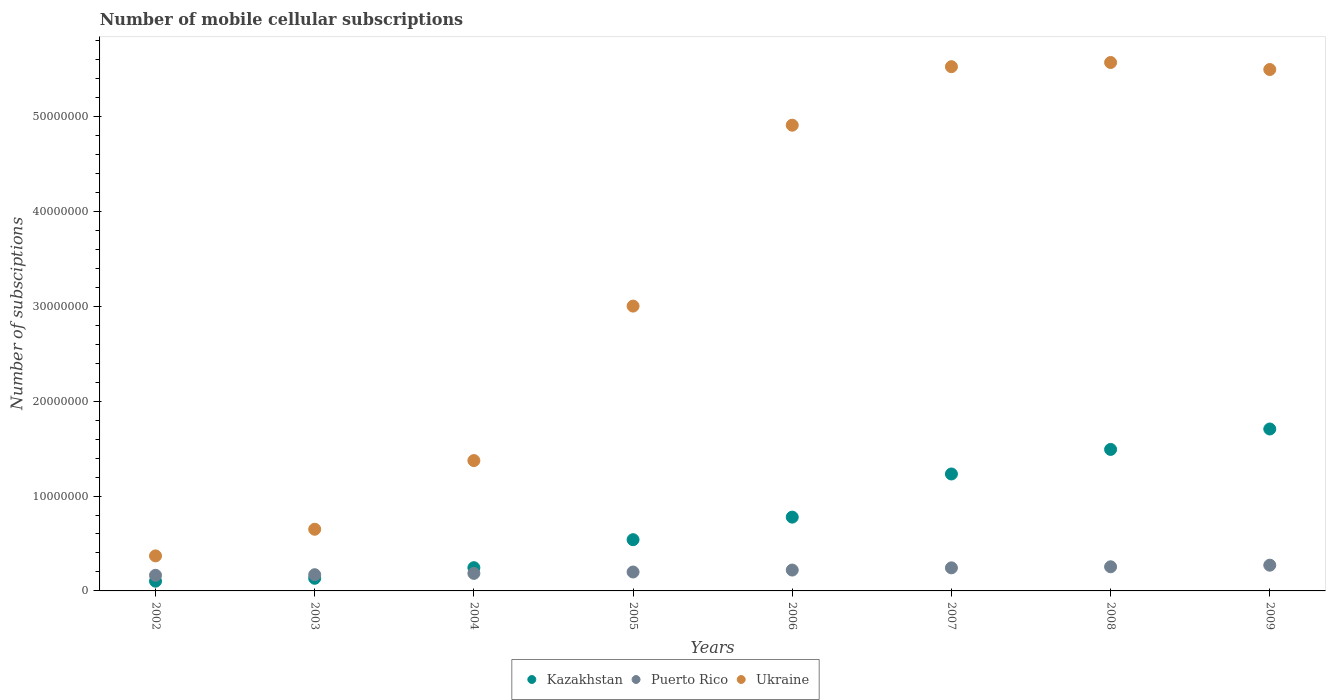What is the number of mobile cellular subscriptions in Kazakhstan in 2004?
Provide a succinct answer. 2.45e+06. Across all years, what is the maximum number of mobile cellular subscriptions in Kazakhstan?
Offer a very short reply. 1.71e+07. Across all years, what is the minimum number of mobile cellular subscriptions in Kazakhstan?
Your answer should be compact. 1.03e+06. In which year was the number of mobile cellular subscriptions in Puerto Rico maximum?
Your answer should be very brief. 2009. In which year was the number of mobile cellular subscriptions in Puerto Rico minimum?
Provide a succinct answer. 2002. What is the total number of mobile cellular subscriptions in Kazakhstan in the graph?
Offer a terse response. 6.23e+07. What is the difference between the number of mobile cellular subscriptions in Puerto Rico in 2004 and that in 2008?
Ensure brevity in your answer.  -6.96e+05. What is the difference between the number of mobile cellular subscriptions in Puerto Rico in 2006 and the number of mobile cellular subscriptions in Kazakhstan in 2007?
Provide a succinct answer. -1.01e+07. What is the average number of mobile cellular subscriptions in Kazakhstan per year?
Keep it short and to the point. 7.78e+06. In the year 2006, what is the difference between the number of mobile cellular subscriptions in Ukraine and number of mobile cellular subscriptions in Kazakhstan?
Your response must be concise. 4.13e+07. What is the ratio of the number of mobile cellular subscriptions in Kazakhstan in 2005 to that in 2007?
Provide a succinct answer. 0.44. Is the difference between the number of mobile cellular subscriptions in Ukraine in 2003 and 2006 greater than the difference between the number of mobile cellular subscriptions in Kazakhstan in 2003 and 2006?
Provide a succinct answer. No. What is the difference between the highest and the second highest number of mobile cellular subscriptions in Kazakhstan?
Make the answer very short. 2.15e+06. What is the difference between the highest and the lowest number of mobile cellular subscriptions in Puerto Rico?
Your answer should be very brief. 1.07e+06. Is the sum of the number of mobile cellular subscriptions in Kazakhstan in 2002 and 2006 greater than the maximum number of mobile cellular subscriptions in Ukraine across all years?
Offer a terse response. No. Is it the case that in every year, the sum of the number of mobile cellular subscriptions in Kazakhstan and number of mobile cellular subscriptions in Ukraine  is greater than the number of mobile cellular subscriptions in Puerto Rico?
Provide a short and direct response. Yes. Does the number of mobile cellular subscriptions in Ukraine monotonically increase over the years?
Make the answer very short. No. Is the number of mobile cellular subscriptions in Kazakhstan strictly greater than the number of mobile cellular subscriptions in Ukraine over the years?
Provide a succinct answer. No. How many dotlines are there?
Your response must be concise. 3. How many years are there in the graph?
Offer a terse response. 8. What is the difference between two consecutive major ticks on the Y-axis?
Your answer should be compact. 1.00e+07. Does the graph contain grids?
Provide a succinct answer. No. Where does the legend appear in the graph?
Offer a very short reply. Bottom center. How are the legend labels stacked?
Offer a terse response. Horizontal. What is the title of the graph?
Provide a succinct answer. Number of mobile cellular subscriptions. What is the label or title of the Y-axis?
Give a very brief answer. Number of subsciptions. What is the Number of subsciptions of Kazakhstan in 2002?
Keep it short and to the point. 1.03e+06. What is the Number of subsciptions of Puerto Rico in 2002?
Provide a short and direct response. 1.65e+06. What is the Number of subsciptions in Ukraine in 2002?
Offer a terse response. 3.69e+06. What is the Number of subsciptions of Kazakhstan in 2003?
Keep it short and to the point. 1.33e+06. What is the Number of subsciptions in Puerto Rico in 2003?
Your response must be concise. 1.71e+06. What is the Number of subsciptions of Ukraine in 2003?
Offer a very short reply. 6.50e+06. What is the Number of subsciptions of Kazakhstan in 2004?
Give a very brief answer. 2.45e+06. What is the Number of subsciptions in Puerto Rico in 2004?
Offer a very short reply. 1.85e+06. What is the Number of subsciptions of Ukraine in 2004?
Keep it short and to the point. 1.37e+07. What is the Number of subsciptions of Kazakhstan in 2005?
Your response must be concise. 5.40e+06. What is the Number of subsciptions in Puerto Rico in 2005?
Provide a short and direct response. 1.99e+06. What is the Number of subsciptions in Ukraine in 2005?
Make the answer very short. 3.00e+07. What is the Number of subsciptions in Kazakhstan in 2006?
Ensure brevity in your answer.  7.78e+06. What is the Number of subsciptions of Puerto Rico in 2006?
Give a very brief answer. 2.20e+06. What is the Number of subsciptions of Ukraine in 2006?
Provide a succinct answer. 4.91e+07. What is the Number of subsciptions of Kazakhstan in 2007?
Give a very brief answer. 1.23e+07. What is the Number of subsciptions of Puerto Rico in 2007?
Provide a short and direct response. 2.43e+06. What is the Number of subsciptions of Ukraine in 2007?
Provide a short and direct response. 5.52e+07. What is the Number of subsciptions in Kazakhstan in 2008?
Your answer should be compact. 1.49e+07. What is the Number of subsciptions of Puerto Rico in 2008?
Provide a short and direct response. 2.54e+06. What is the Number of subsciptions of Ukraine in 2008?
Make the answer very short. 5.57e+07. What is the Number of subsciptions in Kazakhstan in 2009?
Your answer should be compact. 1.71e+07. What is the Number of subsciptions of Puerto Rico in 2009?
Make the answer very short. 2.71e+06. What is the Number of subsciptions of Ukraine in 2009?
Ensure brevity in your answer.  5.49e+07. Across all years, what is the maximum Number of subsciptions in Kazakhstan?
Provide a short and direct response. 1.71e+07. Across all years, what is the maximum Number of subsciptions of Puerto Rico?
Ensure brevity in your answer.  2.71e+06. Across all years, what is the maximum Number of subsciptions of Ukraine?
Give a very brief answer. 5.57e+07. Across all years, what is the minimum Number of subsciptions in Kazakhstan?
Make the answer very short. 1.03e+06. Across all years, what is the minimum Number of subsciptions of Puerto Rico?
Keep it short and to the point. 1.65e+06. Across all years, what is the minimum Number of subsciptions in Ukraine?
Offer a terse response. 3.69e+06. What is the total Number of subsciptions of Kazakhstan in the graph?
Offer a very short reply. 6.23e+07. What is the total Number of subsciptions in Puerto Rico in the graph?
Provide a short and direct response. 1.71e+07. What is the total Number of subsciptions of Ukraine in the graph?
Make the answer very short. 2.69e+08. What is the difference between the Number of subsciptions in Kazakhstan in 2002 and that in 2003?
Offer a terse response. -3.04e+05. What is the difference between the Number of subsciptions in Puerto Rico in 2002 and that in 2003?
Your response must be concise. -6.21e+04. What is the difference between the Number of subsciptions of Ukraine in 2002 and that in 2003?
Your answer should be very brief. -2.81e+06. What is the difference between the Number of subsciptions in Kazakhstan in 2002 and that in 2004?
Your response must be concise. -1.42e+06. What is the difference between the Number of subsciptions of Puerto Rico in 2002 and that in 2004?
Provide a succinct answer. -2.01e+05. What is the difference between the Number of subsciptions of Ukraine in 2002 and that in 2004?
Keep it short and to the point. -1.00e+07. What is the difference between the Number of subsciptions of Kazakhstan in 2002 and that in 2005?
Ensure brevity in your answer.  -4.37e+06. What is the difference between the Number of subsciptions of Puerto Rico in 2002 and that in 2005?
Ensure brevity in your answer.  -3.47e+05. What is the difference between the Number of subsciptions in Ukraine in 2002 and that in 2005?
Offer a terse response. -2.63e+07. What is the difference between the Number of subsciptions in Kazakhstan in 2002 and that in 2006?
Provide a succinct answer. -6.75e+06. What is the difference between the Number of subsciptions of Puerto Rico in 2002 and that in 2006?
Provide a succinct answer. -5.52e+05. What is the difference between the Number of subsciptions in Ukraine in 2002 and that in 2006?
Give a very brief answer. -4.54e+07. What is the difference between the Number of subsciptions in Kazakhstan in 2002 and that in 2007?
Keep it short and to the point. -1.13e+07. What is the difference between the Number of subsciptions in Puerto Rico in 2002 and that in 2007?
Ensure brevity in your answer.  -7.85e+05. What is the difference between the Number of subsciptions in Ukraine in 2002 and that in 2007?
Offer a terse response. -5.15e+07. What is the difference between the Number of subsciptions in Kazakhstan in 2002 and that in 2008?
Offer a very short reply. -1.39e+07. What is the difference between the Number of subsciptions in Puerto Rico in 2002 and that in 2008?
Give a very brief answer. -8.97e+05. What is the difference between the Number of subsciptions in Ukraine in 2002 and that in 2008?
Make the answer very short. -5.20e+07. What is the difference between the Number of subsciptions of Kazakhstan in 2002 and that in 2009?
Your answer should be very brief. -1.60e+07. What is the difference between the Number of subsciptions in Puerto Rico in 2002 and that in 2009?
Keep it short and to the point. -1.07e+06. What is the difference between the Number of subsciptions in Ukraine in 2002 and that in 2009?
Ensure brevity in your answer.  -5.13e+07. What is the difference between the Number of subsciptions in Kazakhstan in 2003 and that in 2004?
Make the answer very short. -1.12e+06. What is the difference between the Number of subsciptions in Puerto Rico in 2003 and that in 2004?
Offer a very short reply. -1.39e+05. What is the difference between the Number of subsciptions in Ukraine in 2003 and that in 2004?
Offer a terse response. -7.24e+06. What is the difference between the Number of subsciptions of Kazakhstan in 2003 and that in 2005?
Your answer should be compact. -4.07e+06. What is the difference between the Number of subsciptions in Puerto Rico in 2003 and that in 2005?
Provide a succinct answer. -2.84e+05. What is the difference between the Number of subsciptions in Ukraine in 2003 and that in 2005?
Keep it short and to the point. -2.35e+07. What is the difference between the Number of subsciptions of Kazakhstan in 2003 and that in 2006?
Your answer should be compact. -6.45e+06. What is the difference between the Number of subsciptions of Puerto Rico in 2003 and that in 2006?
Offer a terse response. -4.90e+05. What is the difference between the Number of subsciptions in Ukraine in 2003 and that in 2006?
Your response must be concise. -4.26e+07. What is the difference between the Number of subsciptions of Kazakhstan in 2003 and that in 2007?
Give a very brief answer. -1.10e+07. What is the difference between the Number of subsciptions in Puerto Rico in 2003 and that in 2007?
Provide a short and direct response. -7.22e+05. What is the difference between the Number of subsciptions of Ukraine in 2003 and that in 2007?
Your response must be concise. -4.87e+07. What is the difference between the Number of subsciptions in Kazakhstan in 2003 and that in 2008?
Provide a short and direct response. -1.36e+07. What is the difference between the Number of subsciptions in Puerto Rico in 2003 and that in 2008?
Give a very brief answer. -8.35e+05. What is the difference between the Number of subsciptions in Ukraine in 2003 and that in 2008?
Your answer should be very brief. -4.92e+07. What is the difference between the Number of subsciptions of Kazakhstan in 2003 and that in 2009?
Ensure brevity in your answer.  -1.57e+07. What is the difference between the Number of subsciptions in Puerto Rico in 2003 and that in 2009?
Give a very brief answer. -1.00e+06. What is the difference between the Number of subsciptions in Ukraine in 2003 and that in 2009?
Offer a very short reply. -4.84e+07. What is the difference between the Number of subsciptions of Kazakhstan in 2004 and that in 2005?
Your answer should be very brief. -2.95e+06. What is the difference between the Number of subsciptions of Puerto Rico in 2004 and that in 2005?
Make the answer very short. -1.46e+05. What is the difference between the Number of subsciptions of Ukraine in 2004 and that in 2005?
Your response must be concise. -1.63e+07. What is the difference between the Number of subsciptions of Kazakhstan in 2004 and that in 2006?
Your response must be concise. -5.33e+06. What is the difference between the Number of subsciptions in Puerto Rico in 2004 and that in 2006?
Give a very brief answer. -3.51e+05. What is the difference between the Number of subsciptions in Ukraine in 2004 and that in 2006?
Ensure brevity in your answer.  -3.53e+07. What is the difference between the Number of subsciptions in Kazakhstan in 2004 and that in 2007?
Your answer should be compact. -9.88e+06. What is the difference between the Number of subsciptions of Puerto Rico in 2004 and that in 2007?
Provide a succinct answer. -5.84e+05. What is the difference between the Number of subsciptions in Ukraine in 2004 and that in 2007?
Provide a succinct answer. -4.15e+07. What is the difference between the Number of subsciptions in Kazakhstan in 2004 and that in 2008?
Make the answer very short. -1.25e+07. What is the difference between the Number of subsciptions in Puerto Rico in 2004 and that in 2008?
Make the answer very short. -6.96e+05. What is the difference between the Number of subsciptions in Ukraine in 2004 and that in 2008?
Your answer should be very brief. -4.19e+07. What is the difference between the Number of subsciptions of Kazakhstan in 2004 and that in 2009?
Your response must be concise. -1.46e+07. What is the difference between the Number of subsciptions of Puerto Rico in 2004 and that in 2009?
Keep it short and to the point. -8.64e+05. What is the difference between the Number of subsciptions of Ukraine in 2004 and that in 2009?
Your answer should be compact. -4.12e+07. What is the difference between the Number of subsciptions in Kazakhstan in 2005 and that in 2006?
Provide a short and direct response. -2.38e+06. What is the difference between the Number of subsciptions in Puerto Rico in 2005 and that in 2006?
Your response must be concise. -2.05e+05. What is the difference between the Number of subsciptions of Ukraine in 2005 and that in 2006?
Ensure brevity in your answer.  -1.91e+07. What is the difference between the Number of subsciptions in Kazakhstan in 2005 and that in 2007?
Your response must be concise. -6.92e+06. What is the difference between the Number of subsciptions of Puerto Rico in 2005 and that in 2007?
Keep it short and to the point. -4.38e+05. What is the difference between the Number of subsciptions of Ukraine in 2005 and that in 2007?
Offer a very short reply. -2.52e+07. What is the difference between the Number of subsciptions of Kazakhstan in 2005 and that in 2008?
Provide a short and direct response. -9.51e+06. What is the difference between the Number of subsciptions in Puerto Rico in 2005 and that in 2008?
Offer a terse response. -5.50e+05. What is the difference between the Number of subsciptions in Ukraine in 2005 and that in 2008?
Offer a terse response. -2.57e+07. What is the difference between the Number of subsciptions in Kazakhstan in 2005 and that in 2009?
Keep it short and to the point. -1.17e+07. What is the difference between the Number of subsciptions in Puerto Rico in 2005 and that in 2009?
Your answer should be very brief. -7.19e+05. What is the difference between the Number of subsciptions in Ukraine in 2005 and that in 2009?
Offer a very short reply. -2.49e+07. What is the difference between the Number of subsciptions of Kazakhstan in 2006 and that in 2007?
Your response must be concise. -4.55e+06. What is the difference between the Number of subsciptions of Puerto Rico in 2006 and that in 2007?
Provide a short and direct response. -2.33e+05. What is the difference between the Number of subsciptions in Ukraine in 2006 and that in 2007?
Provide a succinct answer. -6.16e+06. What is the difference between the Number of subsciptions of Kazakhstan in 2006 and that in 2008?
Keep it short and to the point. -7.13e+06. What is the difference between the Number of subsciptions in Puerto Rico in 2006 and that in 2008?
Give a very brief answer. -3.45e+05. What is the difference between the Number of subsciptions of Ukraine in 2006 and that in 2008?
Your answer should be very brief. -6.61e+06. What is the difference between the Number of subsciptions in Kazakhstan in 2006 and that in 2009?
Your answer should be very brief. -9.29e+06. What is the difference between the Number of subsciptions of Puerto Rico in 2006 and that in 2009?
Your answer should be compact. -5.13e+05. What is the difference between the Number of subsciptions of Ukraine in 2006 and that in 2009?
Provide a short and direct response. -5.87e+06. What is the difference between the Number of subsciptions of Kazakhstan in 2007 and that in 2008?
Make the answer very short. -2.59e+06. What is the difference between the Number of subsciptions of Puerto Rico in 2007 and that in 2008?
Make the answer very short. -1.12e+05. What is the difference between the Number of subsciptions in Ukraine in 2007 and that in 2008?
Offer a terse response. -4.41e+05. What is the difference between the Number of subsciptions of Kazakhstan in 2007 and that in 2009?
Keep it short and to the point. -4.74e+06. What is the difference between the Number of subsciptions of Puerto Rico in 2007 and that in 2009?
Make the answer very short. -2.81e+05. What is the difference between the Number of subsciptions of Ukraine in 2007 and that in 2009?
Provide a succinct answer. 2.98e+05. What is the difference between the Number of subsciptions of Kazakhstan in 2008 and that in 2009?
Keep it short and to the point. -2.15e+06. What is the difference between the Number of subsciptions in Puerto Rico in 2008 and that in 2009?
Provide a succinct answer. -1.69e+05. What is the difference between the Number of subsciptions of Ukraine in 2008 and that in 2009?
Ensure brevity in your answer.  7.39e+05. What is the difference between the Number of subsciptions of Kazakhstan in 2002 and the Number of subsciptions of Puerto Rico in 2003?
Keep it short and to the point. -6.82e+05. What is the difference between the Number of subsciptions in Kazakhstan in 2002 and the Number of subsciptions in Ukraine in 2003?
Offer a very short reply. -5.47e+06. What is the difference between the Number of subsciptions in Puerto Rico in 2002 and the Number of subsciptions in Ukraine in 2003?
Your answer should be compact. -4.85e+06. What is the difference between the Number of subsciptions in Kazakhstan in 2002 and the Number of subsciptions in Puerto Rico in 2004?
Your answer should be very brief. -8.21e+05. What is the difference between the Number of subsciptions of Kazakhstan in 2002 and the Number of subsciptions of Ukraine in 2004?
Offer a very short reply. -1.27e+07. What is the difference between the Number of subsciptions in Puerto Rico in 2002 and the Number of subsciptions in Ukraine in 2004?
Your response must be concise. -1.21e+07. What is the difference between the Number of subsciptions in Kazakhstan in 2002 and the Number of subsciptions in Puerto Rico in 2005?
Ensure brevity in your answer.  -9.66e+05. What is the difference between the Number of subsciptions of Kazakhstan in 2002 and the Number of subsciptions of Ukraine in 2005?
Provide a succinct answer. -2.90e+07. What is the difference between the Number of subsciptions of Puerto Rico in 2002 and the Number of subsciptions of Ukraine in 2005?
Your response must be concise. -2.84e+07. What is the difference between the Number of subsciptions in Kazakhstan in 2002 and the Number of subsciptions in Puerto Rico in 2006?
Your response must be concise. -1.17e+06. What is the difference between the Number of subsciptions in Kazakhstan in 2002 and the Number of subsciptions in Ukraine in 2006?
Your answer should be compact. -4.80e+07. What is the difference between the Number of subsciptions in Puerto Rico in 2002 and the Number of subsciptions in Ukraine in 2006?
Provide a short and direct response. -4.74e+07. What is the difference between the Number of subsciptions in Kazakhstan in 2002 and the Number of subsciptions in Puerto Rico in 2007?
Offer a terse response. -1.40e+06. What is the difference between the Number of subsciptions of Kazakhstan in 2002 and the Number of subsciptions of Ukraine in 2007?
Make the answer very short. -5.42e+07. What is the difference between the Number of subsciptions in Puerto Rico in 2002 and the Number of subsciptions in Ukraine in 2007?
Offer a terse response. -5.36e+07. What is the difference between the Number of subsciptions of Kazakhstan in 2002 and the Number of subsciptions of Puerto Rico in 2008?
Offer a very short reply. -1.52e+06. What is the difference between the Number of subsciptions in Kazakhstan in 2002 and the Number of subsciptions in Ukraine in 2008?
Give a very brief answer. -5.47e+07. What is the difference between the Number of subsciptions of Puerto Rico in 2002 and the Number of subsciptions of Ukraine in 2008?
Your answer should be compact. -5.40e+07. What is the difference between the Number of subsciptions of Kazakhstan in 2002 and the Number of subsciptions of Puerto Rico in 2009?
Offer a very short reply. -1.69e+06. What is the difference between the Number of subsciptions in Kazakhstan in 2002 and the Number of subsciptions in Ukraine in 2009?
Offer a very short reply. -5.39e+07. What is the difference between the Number of subsciptions in Puerto Rico in 2002 and the Number of subsciptions in Ukraine in 2009?
Your response must be concise. -5.33e+07. What is the difference between the Number of subsciptions in Kazakhstan in 2003 and the Number of subsciptions in Puerto Rico in 2004?
Provide a succinct answer. -5.17e+05. What is the difference between the Number of subsciptions in Kazakhstan in 2003 and the Number of subsciptions in Ukraine in 2004?
Your answer should be compact. -1.24e+07. What is the difference between the Number of subsciptions in Puerto Rico in 2003 and the Number of subsciptions in Ukraine in 2004?
Ensure brevity in your answer.  -1.20e+07. What is the difference between the Number of subsciptions of Kazakhstan in 2003 and the Number of subsciptions of Puerto Rico in 2005?
Your answer should be very brief. -6.63e+05. What is the difference between the Number of subsciptions of Kazakhstan in 2003 and the Number of subsciptions of Ukraine in 2005?
Offer a very short reply. -2.87e+07. What is the difference between the Number of subsciptions of Puerto Rico in 2003 and the Number of subsciptions of Ukraine in 2005?
Ensure brevity in your answer.  -2.83e+07. What is the difference between the Number of subsciptions of Kazakhstan in 2003 and the Number of subsciptions of Puerto Rico in 2006?
Give a very brief answer. -8.68e+05. What is the difference between the Number of subsciptions of Kazakhstan in 2003 and the Number of subsciptions of Ukraine in 2006?
Make the answer very short. -4.77e+07. What is the difference between the Number of subsciptions of Puerto Rico in 2003 and the Number of subsciptions of Ukraine in 2006?
Offer a terse response. -4.74e+07. What is the difference between the Number of subsciptions of Kazakhstan in 2003 and the Number of subsciptions of Puerto Rico in 2007?
Ensure brevity in your answer.  -1.10e+06. What is the difference between the Number of subsciptions of Kazakhstan in 2003 and the Number of subsciptions of Ukraine in 2007?
Your answer should be very brief. -5.39e+07. What is the difference between the Number of subsciptions of Puerto Rico in 2003 and the Number of subsciptions of Ukraine in 2007?
Your answer should be compact. -5.35e+07. What is the difference between the Number of subsciptions of Kazakhstan in 2003 and the Number of subsciptions of Puerto Rico in 2008?
Your answer should be very brief. -1.21e+06. What is the difference between the Number of subsciptions in Kazakhstan in 2003 and the Number of subsciptions in Ukraine in 2008?
Ensure brevity in your answer.  -5.44e+07. What is the difference between the Number of subsciptions of Puerto Rico in 2003 and the Number of subsciptions of Ukraine in 2008?
Your answer should be compact. -5.40e+07. What is the difference between the Number of subsciptions in Kazakhstan in 2003 and the Number of subsciptions in Puerto Rico in 2009?
Your response must be concise. -1.38e+06. What is the difference between the Number of subsciptions in Kazakhstan in 2003 and the Number of subsciptions in Ukraine in 2009?
Your answer should be very brief. -5.36e+07. What is the difference between the Number of subsciptions of Puerto Rico in 2003 and the Number of subsciptions of Ukraine in 2009?
Your answer should be very brief. -5.32e+07. What is the difference between the Number of subsciptions in Kazakhstan in 2004 and the Number of subsciptions in Puerto Rico in 2005?
Provide a short and direct response. 4.54e+05. What is the difference between the Number of subsciptions of Kazakhstan in 2004 and the Number of subsciptions of Ukraine in 2005?
Give a very brief answer. -2.76e+07. What is the difference between the Number of subsciptions in Puerto Rico in 2004 and the Number of subsciptions in Ukraine in 2005?
Give a very brief answer. -2.82e+07. What is the difference between the Number of subsciptions in Kazakhstan in 2004 and the Number of subsciptions in Puerto Rico in 2006?
Keep it short and to the point. 2.48e+05. What is the difference between the Number of subsciptions in Kazakhstan in 2004 and the Number of subsciptions in Ukraine in 2006?
Make the answer very short. -4.66e+07. What is the difference between the Number of subsciptions in Puerto Rico in 2004 and the Number of subsciptions in Ukraine in 2006?
Your response must be concise. -4.72e+07. What is the difference between the Number of subsciptions in Kazakhstan in 2004 and the Number of subsciptions in Puerto Rico in 2007?
Your answer should be very brief. 1.55e+04. What is the difference between the Number of subsciptions in Kazakhstan in 2004 and the Number of subsciptions in Ukraine in 2007?
Offer a terse response. -5.28e+07. What is the difference between the Number of subsciptions in Puerto Rico in 2004 and the Number of subsciptions in Ukraine in 2007?
Keep it short and to the point. -5.34e+07. What is the difference between the Number of subsciptions of Kazakhstan in 2004 and the Number of subsciptions of Puerto Rico in 2008?
Provide a short and direct response. -9.66e+04. What is the difference between the Number of subsciptions of Kazakhstan in 2004 and the Number of subsciptions of Ukraine in 2008?
Your answer should be very brief. -5.32e+07. What is the difference between the Number of subsciptions of Puerto Rico in 2004 and the Number of subsciptions of Ukraine in 2008?
Give a very brief answer. -5.38e+07. What is the difference between the Number of subsciptions in Kazakhstan in 2004 and the Number of subsciptions in Puerto Rico in 2009?
Ensure brevity in your answer.  -2.65e+05. What is the difference between the Number of subsciptions in Kazakhstan in 2004 and the Number of subsciptions in Ukraine in 2009?
Provide a short and direct response. -5.25e+07. What is the difference between the Number of subsciptions in Puerto Rico in 2004 and the Number of subsciptions in Ukraine in 2009?
Offer a very short reply. -5.31e+07. What is the difference between the Number of subsciptions in Kazakhstan in 2005 and the Number of subsciptions in Puerto Rico in 2006?
Offer a terse response. 3.20e+06. What is the difference between the Number of subsciptions in Kazakhstan in 2005 and the Number of subsciptions in Ukraine in 2006?
Your answer should be very brief. -4.37e+07. What is the difference between the Number of subsciptions of Puerto Rico in 2005 and the Number of subsciptions of Ukraine in 2006?
Your answer should be very brief. -4.71e+07. What is the difference between the Number of subsciptions of Kazakhstan in 2005 and the Number of subsciptions of Puerto Rico in 2007?
Your answer should be very brief. 2.97e+06. What is the difference between the Number of subsciptions in Kazakhstan in 2005 and the Number of subsciptions in Ukraine in 2007?
Keep it short and to the point. -4.98e+07. What is the difference between the Number of subsciptions of Puerto Rico in 2005 and the Number of subsciptions of Ukraine in 2007?
Give a very brief answer. -5.32e+07. What is the difference between the Number of subsciptions in Kazakhstan in 2005 and the Number of subsciptions in Puerto Rico in 2008?
Give a very brief answer. 2.85e+06. What is the difference between the Number of subsciptions in Kazakhstan in 2005 and the Number of subsciptions in Ukraine in 2008?
Provide a short and direct response. -5.03e+07. What is the difference between the Number of subsciptions of Puerto Rico in 2005 and the Number of subsciptions of Ukraine in 2008?
Your response must be concise. -5.37e+07. What is the difference between the Number of subsciptions of Kazakhstan in 2005 and the Number of subsciptions of Puerto Rico in 2009?
Your answer should be compact. 2.69e+06. What is the difference between the Number of subsciptions of Kazakhstan in 2005 and the Number of subsciptions of Ukraine in 2009?
Offer a terse response. -4.95e+07. What is the difference between the Number of subsciptions in Puerto Rico in 2005 and the Number of subsciptions in Ukraine in 2009?
Your answer should be very brief. -5.29e+07. What is the difference between the Number of subsciptions of Kazakhstan in 2006 and the Number of subsciptions of Puerto Rico in 2007?
Make the answer very short. 5.34e+06. What is the difference between the Number of subsciptions of Kazakhstan in 2006 and the Number of subsciptions of Ukraine in 2007?
Ensure brevity in your answer.  -4.75e+07. What is the difference between the Number of subsciptions of Puerto Rico in 2006 and the Number of subsciptions of Ukraine in 2007?
Your response must be concise. -5.30e+07. What is the difference between the Number of subsciptions in Kazakhstan in 2006 and the Number of subsciptions in Puerto Rico in 2008?
Provide a short and direct response. 5.23e+06. What is the difference between the Number of subsciptions in Kazakhstan in 2006 and the Number of subsciptions in Ukraine in 2008?
Provide a succinct answer. -4.79e+07. What is the difference between the Number of subsciptions in Puerto Rico in 2006 and the Number of subsciptions in Ukraine in 2008?
Your answer should be very brief. -5.35e+07. What is the difference between the Number of subsciptions of Kazakhstan in 2006 and the Number of subsciptions of Puerto Rico in 2009?
Offer a terse response. 5.06e+06. What is the difference between the Number of subsciptions in Kazakhstan in 2006 and the Number of subsciptions in Ukraine in 2009?
Offer a terse response. -4.72e+07. What is the difference between the Number of subsciptions of Puerto Rico in 2006 and the Number of subsciptions of Ukraine in 2009?
Provide a succinct answer. -5.27e+07. What is the difference between the Number of subsciptions of Kazakhstan in 2007 and the Number of subsciptions of Puerto Rico in 2008?
Keep it short and to the point. 9.78e+06. What is the difference between the Number of subsciptions of Kazakhstan in 2007 and the Number of subsciptions of Ukraine in 2008?
Give a very brief answer. -4.34e+07. What is the difference between the Number of subsciptions of Puerto Rico in 2007 and the Number of subsciptions of Ukraine in 2008?
Your answer should be very brief. -5.32e+07. What is the difference between the Number of subsciptions in Kazakhstan in 2007 and the Number of subsciptions in Puerto Rico in 2009?
Your answer should be very brief. 9.61e+06. What is the difference between the Number of subsciptions in Kazakhstan in 2007 and the Number of subsciptions in Ukraine in 2009?
Your response must be concise. -4.26e+07. What is the difference between the Number of subsciptions in Puerto Rico in 2007 and the Number of subsciptions in Ukraine in 2009?
Make the answer very short. -5.25e+07. What is the difference between the Number of subsciptions in Kazakhstan in 2008 and the Number of subsciptions in Puerto Rico in 2009?
Keep it short and to the point. 1.22e+07. What is the difference between the Number of subsciptions of Kazakhstan in 2008 and the Number of subsciptions of Ukraine in 2009?
Give a very brief answer. -4.00e+07. What is the difference between the Number of subsciptions in Puerto Rico in 2008 and the Number of subsciptions in Ukraine in 2009?
Your answer should be very brief. -5.24e+07. What is the average Number of subsciptions in Kazakhstan per year?
Make the answer very short. 7.78e+06. What is the average Number of subsciptions in Puerto Rico per year?
Offer a very short reply. 2.14e+06. What is the average Number of subsciptions of Ukraine per year?
Ensure brevity in your answer.  3.36e+07. In the year 2002, what is the difference between the Number of subsciptions of Kazakhstan and Number of subsciptions of Puerto Rico?
Your answer should be very brief. -6.20e+05. In the year 2002, what is the difference between the Number of subsciptions in Kazakhstan and Number of subsciptions in Ukraine?
Your answer should be very brief. -2.67e+06. In the year 2002, what is the difference between the Number of subsciptions of Puerto Rico and Number of subsciptions of Ukraine?
Your answer should be very brief. -2.05e+06. In the year 2003, what is the difference between the Number of subsciptions in Kazakhstan and Number of subsciptions in Puerto Rico?
Provide a short and direct response. -3.78e+05. In the year 2003, what is the difference between the Number of subsciptions of Kazakhstan and Number of subsciptions of Ukraine?
Provide a succinct answer. -5.17e+06. In the year 2003, what is the difference between the Number of subsciptions of Puerto Rico and Number of subsciptions of Ukraine?
Keep it short and to the point. -4.79e+06. In the year 2004, what is the difference between the Number of subsciptions of Kazakhstan and Number of subsciptions of Puerto Rico?
Offer a terse response. 5.99e+05. In the year 2004, what is the difference between the Number of subsciptions in Kazakhstan and Number of subsciptions in Ukraine?
Your answer should be compact. -1.13e+07. In the year 2004, what is the difference between the Number of subsciptions of Puerto Rico and Number of subsciptions of Ukraine?
Your answer should be very brief. -1.19e+07. In the year 2005, what is the difference between the Number of subsciptions in Kazakhstan and Number of subsciptions in Puerto Rico?
Your answer should be compact. 3.40e+06. In the year 2005, what is the difference between the Number of subsciptions in Kazakhstan and Number of subsciptions in Ukraine?
Your answer should be compact. -2.46e+07. In the year 2005, what is the difference between the Number of subsciptions of Puerto Rico and Number of subsciptions of Ukraine?
Make the answer very short. -2.80e+07. In the year 2006, what is the difference between the Number of subsciptions in Kazakhstan and Number of subsciptions in Puerto Rico?
Your answer should be compact. 5.58e+06. In the year 2006, what is the difference between the Number of subsciptions in Kazakhstan and Number of subsciptions in Ukraine?
Offer a terse response. -4.13e+07. In the year 2006, what is the difference between the Number of subsciptions of Puerto Rico and Number of subsciptions of Ukraine?
Ensure brevity in your answer.  -4.69e+07. In the year 2007, what is the difference between the Number of subsciptions of Kazakhstan and Number of subsciptions of Puerto Rico?
Give a very brief answer. 9.89e+06. In the year 2007, what is the difference between the Number of subsciptions in Kazakhstan and Number of subsciptions in Ukraine?
Your answer should be very brief. -4.29e+07. In the year 2007, what is the difference between the Number of subsciptions of Puerto Rico and Number of subsciptions of Ukraine?
Make the answer very short. -5.28e+07. In the year 2008, what is the difference between the Number of subsciptions in Kazakhstan and Number of subsciptions in Puerto Rico?
Keep it short and to the point. 1.24e+07. In the year 2008, what is the difference between the Number of subsciptions of Kazakhstan and Number of subsciptions of Ukraine?
Ensure brevity in your answer.  -4.08e+07. In the year 2008, what is the difference between the Number of subsciptions of Puerto Rico and Number of subsciptions of Ukraine?
Offer a very short reply. -5.31e+07. In the year 2009, what is the difference between the Number of subsciptions of Kazakhstan and Number of subsciptions of Puerto Rico?
Provide a succinct answer. 1.44e+07. In the year 2009, what is the difference between the Number of subsciptions in Kazakhstan and Number of subsciptions in Ukraine?
Your answer should be very brief. -3.79e+07. In the year 2009, what is the difference between the Number of subsciptions of Puerto Rico and Number of subsciptions of Ukraine?
Your response must be concise. -5.22e+07. What is the ratio of the Number of subsciptions of Kazakhstan in 2002 to that in 2003?
Give a very brief answer. 0.77. What is the ratio of the Number of subsciptions of Puerto Rico in 2002 to that in 2003?
Your answer should be compact. 0.96. What is the ratio of the Number of subsciptions in Ukraine in 2002 to that in 2003?
Your answer should be compact. 0.57. What is the ratio of the Number of subsciptions of Kazakhstan in 2002 to that in 2004?
Your response must be concise. 0.42. What is the ratio of the Number of subsciptions of Puerto Rico in 2002 to that in 2004?
Provide a succinct answer. 0.89. What is the ratio of the Number of subsciptions of Ukraine in 2002 to that in 2004?
Provide a short and direct response. 0.27. What is the ratio of the Number of subsciptions in Kazakhstan in 2002 to that in 2005?
Your answer should be compact. 0.19. What is the ratio of the Number of subsciptions in Puerto Rico in 2002 to that in 2005?
Offer a very short reply. 0.83. What is the ratio of the Number of subsciptions in Ukraine in 2002 to that in 2005?
Ensure brevity in your answer.  0.12. What is the ratio of the Number of subsciptions in Kazakhstan in 2002 to that in 2006?
Your answer should be very brief. 0.13. What is the ratio of the Number of subsciptions of Puerto Rico in 2002 to that in 2006?
Your answer should be very brief. 0.75. What is the ratio of the Number of subsciptions of Ukraine in 2002 to that in 2006?
Provide a succinct answer. 0.08. What is the ratio of the Number of subsciptions in Kazakhstan in 2002 to that in 2007?
Ensure brevity in your answer.  0.08. What is the ratio of the Number of subsciptions of Puerto Rico in 2002 to that in 2007?
Your answer should be compact. 0.68. What is the ratio of the Number of subsciptions in Ukraine in 2002 to that in 2007?
Provide a short and direct response. 0.07. What is the ratio of the Number of subsciptions of Kazakhstan in 2002 to that in 2008?
Provide a succinct answer. 0.07. What is the ratio of the Number of subsciptions in Puerto Rico in 2002 to that in 2008?
Offer a terse response. 0.65. What is the ratio of the Number of subsciptions of Ukraine in 2002 to that in 2008?
Provide a short and direct response. 0.07. What is the ratio of the Number of subsciptions of Kazakhstan in 2002 to that in 2009?
Ensure brevity in your answer.  0.06. What is the ratio of the Number of subsciptions of Puerto Rico in 2002 to that in 2009?
Make the answer very short. 0.61. What is the ratio of the Number of subsciptions of Ukraine in 2002 to that in 2009?
Make the answer very short. 0.07. What is the ratio of the Number of subsciptions of Kazakhstan in 2003 to that in 2004?
Your response must be concise. 0.54. What is the ratio of the Number of subsciptions in Puerto Rico in 2003 to that in 2004?
Provide a succinct answer. 0.92. What is the ratio of the Number of subsciptions of Ukraine in 2003 to that in 2004?
Make the answer very short. 0.47. What is the ratio of the Number of subsciptions in Kazakhstan in 2003 to that in 2005?
Offer a very short reply. 0.25. What is the ratio of the Number of subsciptions of Puerto Rico in 2003 to that in 2005?
Ensure brevity in your answer.  0.86. What is the ratio of the Number of subsciptions in Ukraine in 2003 to that in 2005?
Give a very brief answer. 0.22. What is the ratio of the Number of subsciptions of Kazakhstan in 2003 to that in 2006?
Keep it short and to the point. 0.17. What is the ratio of the Number of subsciptions of Puerto Rico in 2003 to that in 2006?
Make the answer very short. 0.78. What is the ratio of the Number of subsciptions of Ukraine in 2003 to that in 2006?
Offer a very short reply. 0.13. What is the ratio of the Number of subsciptions in Kazakhstan in 2003 to that in 2007?
Your answer should be compact. 0.11. What is the ratio of the Number of subsciptions in Puerto Rico in 2003 to that in 2007?
Give a very brief answer. 0.7. What is the ratio of the Number of subsciptions of Ukraine in 2003 to that in 2007?
Offer a very short reply. 0.12. What is the ratio of the Number of subsciptions of Kazakhstan in 2003 to that in 2008?
Offer a very short reply. 0.09. What is the ratio of the Number of subsciptions of Puerto Rico in 2003 to that in 2008?
Make the answer very short. 0.67. What is the ratio of the Number of subsciptions of Ukraine in 2003 to that in 2008?
Your answer should be compact. 0.12. What is the ratio of the Number of subsciptions in Kazakhstan in 2003 to that in 2009?
Give a very brief answer. 0.08. What is the ratio of the Number of subsciptions of Puerto Rico in 2003 to that in 2009?
Your answer should be very brief. 0.63. What is the ratio of the Number of subsciptions of Ukraine in 2003 to that in 2009?
Your answer should be compact. 0.12. What is the ratio of the Number of subsciptions in Kazakhstan in 2004 to that in 2005?
Ensure brevity in your answer.  0.45. What is the ratio of the Number of subsciptions in Puerto Rico in 2004 to that in 2005?
Give a very brief answer. 0.93. What is the ratio of the Number of subsciptions of Ukraine in 2004 to that in 2005?
Make the answer very short. 0.46. What is the ratio of the Number of subsciptions of Kazakhstan in 2004 to that in 2006?
Make the answer very short. 0.31. What is the ratio of the Number of subsciptions of Puerto Rico in 2004 to that in 2006?
Your response must be concise. 0.84. What is the ratio of the Number of subsciptions in Ukraine in 2004 to that in 2006?
Offer a terse response. 0.28. What is the ratio of the Number of subsciptions in Kazakhstan in 2004 to that in 2007?
Your answer should be very brief. 0.2. What is the ratio of the Number of subsciptions in Puerto Rico in 2004 to that in 2007?
Ensure brevity in your answer.  0.76. What is the ratio of the Number of subsciptions in Ukraine in 2004 to that in 2007?
Your response must be concise. 0.25. What is the ratio of the Number of subsciptions of Kazakhstan in 2004 to that in 2008?
Offer a very short reply. 0.16. What is the ratio of the Number of subsciptions of Puerto Rico in 2004 to that in 2008?
Provide a short and direct response. 0.73. What is the ratio of the Number of subsciptions in Ukraine in 2004 to that in 2008?
Your answer should be very brief. 0.25. What is the ratio of the Number of subsciptions in Kazakhstan in 2004 to that in 2009?
Provide a short and direct response. 0.14. What is the ratio of the Number of subsciptions in Puerto Rico in 2004 to that in 2009?
Offer a terse response. 0.68. What is the ratio of the Number of subsciptions of Kazakhstan in 2005 to that in 2006?
Keep it short and to the point. 0.69. What is the ratio of the Number of subsciptions in Puerto Rico in 2005 to that in 2006?
Offer a very short reply. 0.91. What is the ratio of the Number of subsciptions in Ukraine in 2005 to that in 2006?
Provide a succinct answer. 0.61. What is the ratio of the Number of subsciptions of Kazakhstan in 2005 to that in 2007?
Your response must be concise. 0.44. What is the ratio of the Number of subsciptions in Puerto Rico in 2005 to that in 2007?
Keep it short and to the point. 0.82. What is the ratio of the Number of subsciptions in Ukraine in 2005 to that in 2007?
Keep it short and to the point. 0.54. What is the ratio of the Number of subsciptions in Kazakhstan in 2005 to that in 2008?
Provide a succinct answer. 0.36. What is the ratio of the Number of subsciptions in Puerto Rico in 2005 to that in 2008?
Offer a terse response. 0.78. What is the ratio of the Number of subsciptions of Ukraine in 2005 to that in 2008?
Provide a succinct answer. 0.54. What is the ratio of the Number of subsciptions of Kazakhstan in 2005 to that in 2009?
Ensure brevity in your answer.  0.32. What is the ratio of the Number of subsciptions of Puerto Rico in 2005 to that in 2009?
Your answer should be very brief. 0.73. What is the ratio of the Number of subsciptions in Ukraine in 2005 to that in 2009?
Make the answer very short. 0.55. What is the ratio of the Number of subsciptions in Kazakhstan in 2006 to that in 2007?
Give a very brief answer. 0.63. What is the ratio of the Number of subsciptions of Puerto Rico in 2006 to that in 2007?
Your answer should be very brief. 0.9. What is the ratio of the Number of subsciptions in Ukraine in 2006 to that in 2007?
Give a very brief answer. 0.89. What is the ratio of the Number of subsciptions of Kazakhstan in 2006 to that in 2008?
Keep it short and to the point. 0.52. What is the ratio of the Number of subsciptions of Puerto Rico in 2006 to that in 2008?
Offer a very short reply. 0.86. What is the ratio of the Number of subsciptions in Ukraine in 2006 to that in 2008?
Your answer should be very brief. 0.88. What is the ratio of the Number of subsciptions of Kazakhstan in 2006 to that in 2009?
Offer a very short reply. 0.46. What is the ratio of the Number of subsciptions in Puerto Rico in 2006 to that in 2009?
Your answer should be very brief. 0.81. What is the ratio of the Number of subsciptions of Ukraine in 2006 to that in 2009?
Offer a terse response. 0.89. What is the ratio of the Number of subsciptions of Kazakhstan in 2007 to that in 2008?
Offer a terse response. 0.83. What is the ratio of the Number of subsciptions of Puerto Rico in 2007 to that in 2008?
Provide a succinct answer. 0.96. What is the ratio of the Number of subsciptions of Kazakhstan in 2007 to that in 2009?
Offer a very short reply. 0.72. What is the ratio of the Number of subsciptions in Puerto Rico in 2007 to that in 2009?
Your answer should be compact. 0.9. What is the ratio of the Number of subsciptions of Ukraine in 2007 to that in 2009?
Keep it short and to the point. 1.01. What is the ratio of the Number of subsciptions of Kazakhstan in 2008 to that in 2009?
Offer a very short reply. 0.87. What is the ratio of the Number of subsciptions in Puerto Rico in 2008 to that in 2009?
Provide a short and direct response. 0.94. What is the ratio of the Number of subsciptions in Ukraine in 2008 to that in 2009?
Make the answer very short. 1.01. What is the difference between the highest and the second highest Number of subsciptions of Kazakhstan?
Offer a terse response. 2.15e+06. What is the difference between the highest and the second highest Number of subsciptions of Puerto Rico?
Give a very brief answer. 1.69e+05. What is the difference between the highest and the second highest Number of subsciptions of Ukraine?
Keep it short and to the point. 4.41e+05. What is the difference between the highest and the lowest Number of subsciptions in Kazakhstan?
Ensure brevity in your answer.  1.60e+07. What is the difference between the highest and the lowest Number of subsciptions of Puerto Rico?
Offer a very short reply. 1.07e+06. What is the difference between the highest and the lowest Number of subsciptions in Ukraine?
Provide a short and direct response. 5.20e+07. 